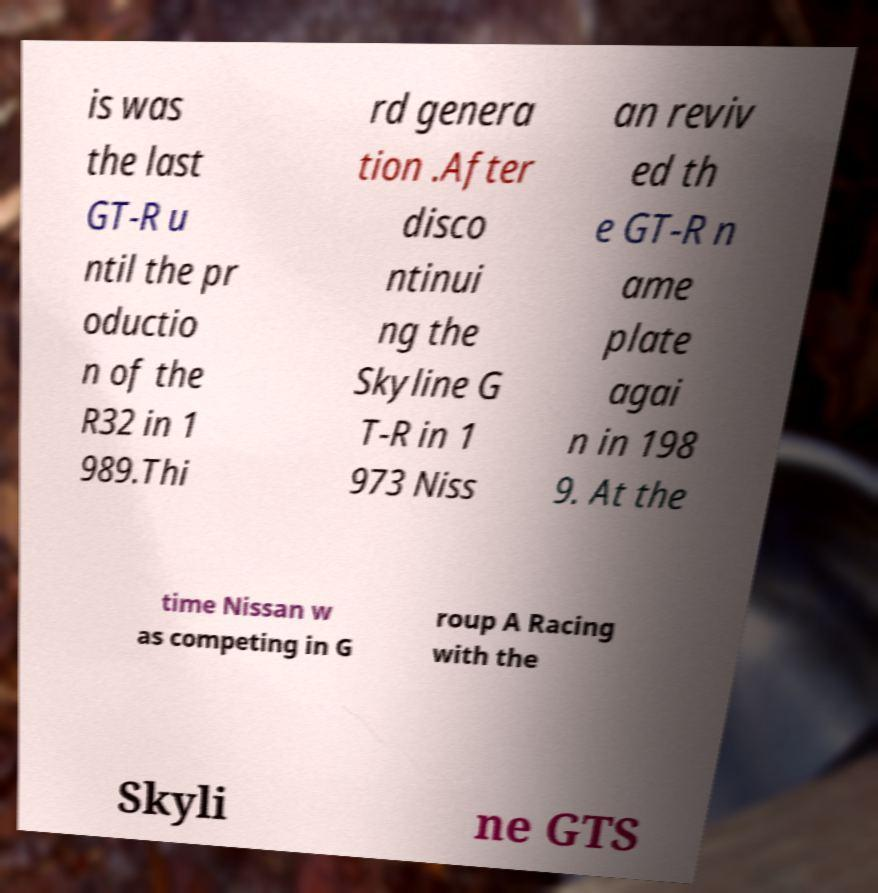Can you accurately transcribe the text from the provided image for me? is was the last GT-R u ntil the pr oductio n of the R32 in 1 989.Thi rd genera tion .After disco ntinui ng the Skyline G T-R in 1 973 Niss an reviv ed th e GT-R n ame plate agai n in 198 9. At the time Nissan w as competing in G roup A Racing with the Skyli ne GTS 